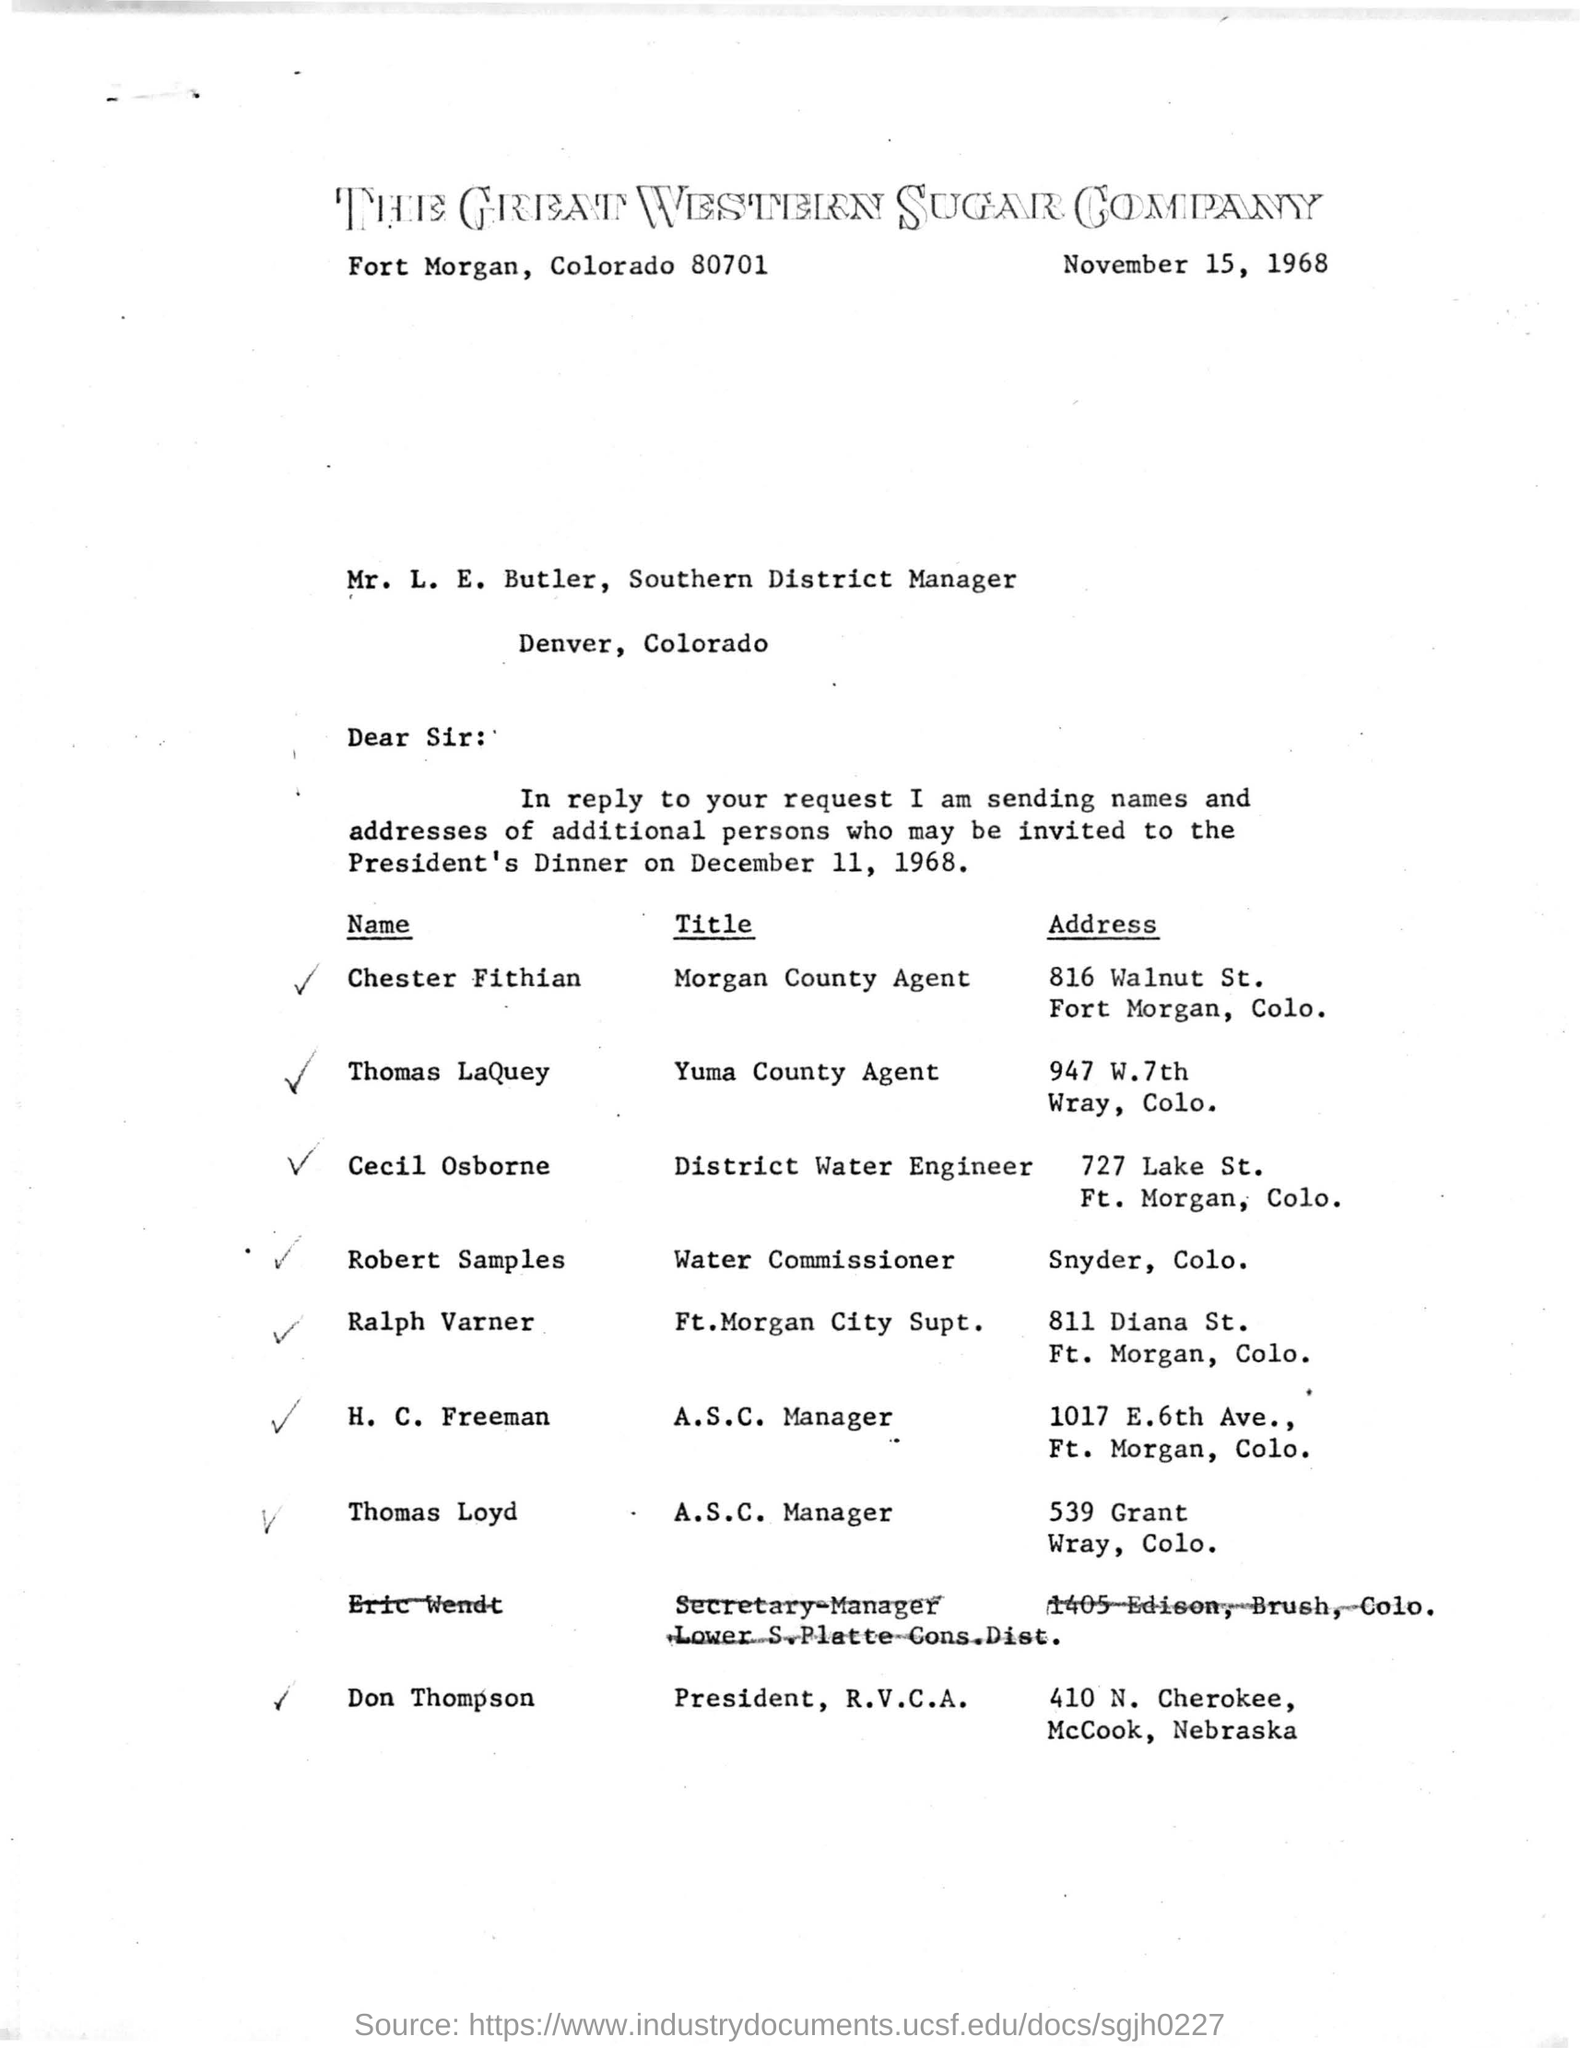Indicate a few pertinent items in this graphic. Chester Fithian is a Morgan County agent. The president's dinner is scheduled for December 11, 1968. 